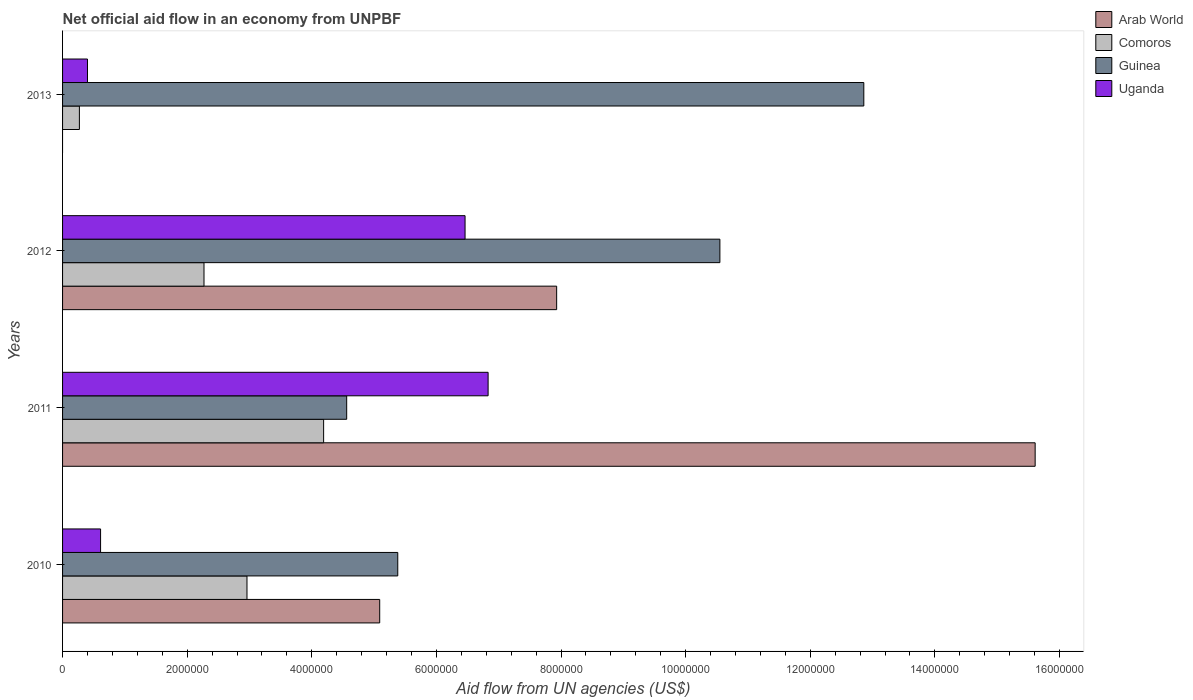How many different coloured bars are there?
Give a very brief answer. 4. Are the number of bars on each tick of the Y-axis equal?
Provide a short and direct response. No. How many bars are there on the 4th tick from the top?
Your response must be concise. 4. How many bars are there on the 4th tick from the bottom?
Offer a very short reply. 3. Across all years, what is the maximum net official aid flow in Comoros?
Offer a very short reply. 4.19e+06. Across all years, what is the minimum net official aid flow in Guinea?
Provide a short and direct response. 4.56e+06. What is the total net official aid flow in Uganda in the graph?
Your answer should be compact. 1.43e+07. What is the difference between the net official aid flow in Uganda in 2012 and that in 2013?
Offer a very short reply. 6.06e+06. What is the difference between the net official aid flow in Guinea in 2013 and the net official aid flow in Uganda in 2012?
Give a very brief answer. 6.40e+06. What is the average net official aid flow in Uganda per year?
Ensure brevity in your answer.  3.58e+06. In the year 2012, what is the difference between the net official aid flow in Uganda and net official aid flow in Comoros?
Make the answer very short. 4.19e+06. In how many years, is the net official aid flow in Guinea greater than 8400000 US$?
Provide a succinct answer. 2. What is the ratio of the net official aid flow in Arab World in 2010 to that in 2012?
Provide a succinct answer. 0.64. Is the net official aid flow in Guinea in 2011 less than that in 2012?
Provide a short and direct response. Yes. What is the difference between the highest and the second highest net official aid flow in Arab World?
Offer a very short reply. 7.68e+06. What is the difference between the highest and the lowest net official aid flow in Comoros?
Offer a terse response. 3.92e+06. Is the sum of the net official aid flow in Comoros in 2010 and 2013 greater than the maximum net official aid flow in Guinea across all years?
Offer a terse response. No. Is it the case that in every year, the sum of the net official aid flow in Arab World and net official aid flow in Uganda is greater than the sum of net official aid flow in Comoros and net official aid flow in Guinea?
Make the answer very short. No. Are all the bars in the graph horizontal?
Offer a very short reply. Yes. What is the difference between two consecutive major ticks on the X-axis?
Provide a succinct answer. 2.00e+06. Are the values on the major ticks of X-axis written in scientific E-notation?
Your answer should be very brief. No. Does the graph contain any zero values?
Ensure brevity in your answer.  Yes. Does the graph contain grids?
Offer a very short reply. No. What is the title of the graph?
Provide a succinct answer. Net official aid flow in an economy from UNPBF. What is the label or title of the X-axis?
Make the answer very short. Aid flow from UN agencies (US$). What is the label or title of the Y-axis?
Offer a terse response. Years. What is the Aid flow from UN agencies (US$) in Arab World in 2010?
Make the answer very short. 5.09e+06. What is the Aid flow from UN agencies (US$) of Comoros in 2010?
Your answer should be very brief. 2.96e+06. What is the Aid flow from UN agencies (US$) in Guinea in 2010?
Keep it short and to the point. 5.38e+06. What is the Aid flow from UN agencies (US$) in Uganda in 2010?
Offer a terse response. 6.10e+05. What is the Aid flow from UN agencies (US$) in Arab World in 2011?
Provide a succinct answer. 1.56e+07. What is the Aid flow from UN agencies (US$) in Comoros in 2011?
Give a very brief answer. 4.19e+06. What is the Aid flow from UN agencies (US$) of Guinea in 2011?
Your answer should be compact. 4.56e+06. What is the Aid flow from UN agencies (US$) in Uganda in 2011?
Offer a very short reply. 6.83e+06. What is the Aid flow from UN agencies (US$) in Arab World in 2012?
Your answer should be very brief. 7.93e+06. What is the Aid flow from UN agencies (US$) in Comoros in 2012?
Make the answer very short. 2.27e+06. What is the Aid flow from UN agencies (US$) of Guinea in 2012?
Your answer should be compact. 1.06e+07. What is the Aid flow from UN agencies (US$) in Uganda in 2012?
Give a very brief answer. 6.46e+06. What is the Aid flow from UN agencies (US$) in Arab World in 2013?
Your response must be concise. 0. What is the Aid flow from UN agencies (US$) in Comoros in 2013?
Your answer should be very brief. 2.70e+05. What is the Aid flow from UN agencies (US$) in Guinea in 2013?
Ensure brevity in your answer.  1.29e+07. What is the Aid flow from UN agencies (US$) in Uganda in 2013?
Your answer should be compact. 4.00e+05. Across all years, what is the maximum Aid flow from UN agencies (US$) in Arab World?
Ensure brevity in your answer.  1.56e+07. Across all years, what is the maximum Aid flow from UN agencies (US$) of Comoros?
Your response must be concise. 4.19e+06. Across all years, what is the maximum Aid flow from UN agencies (US$) of Guinea?
Your answer should be very brief. 1.29e+07. Across all years, what is the maximum Aid flow from UN agencies (US$) in Uganda?
Your answer should be compact. 6.83e+06. Across all years, what is the minimum Aid flow from UN agencies (US$) in Guinea?
Provide a succinct answer. 4.56e+06. What is the total Aid flow from UN agencies (US$) in Arab World in the graph?
Provide a short and direct response. 2.86e+07. What is the total Aid flow from UN agencies (US$) of Comoros in the graph?
Provide a short and direct response. 9.69e+06. What is the total Aid flow from UN agencies (US$) in Guinea in the graph?
Provide a short and direct response. 3.34e+07. What is the total Aid flow from UN agencies (US$) of Uganda in the graph?
Offer a very short reply. 1.43e+07. What is the difference between the Aid flow from UN agencies (US$) of Arab World in 2010 and that in 2011?
Provide a short and direct response. -1.05e+07. What is the difference between the Aid flow from UN agencies (US$) of Comoros in 2010 and that in 2011?
Provide a succinct answer. -1.23e+06. What is the difference between the Aid flow from UN agencies (US$) in Guinea in 2010 and that in 2011?
Your response must be concise. 8.20e+05. What is the difference between the Aid flow from UN agencies (US$) of Uganda in 2010 and that in 2011?
Give a very brief answer. -6.22e+06. What is the difference between the Aid flow from UN agencies (US$) of Arab World in 2010 and that in 2012?
Provide a succinct answer. -2.84e+06. What is the difference between the Aid flow from UN agencies (US$) of Comoros in 2010 and that in 2012?
Offer a terse response. 6.90e+05. What is the difference between the Aid flow from UN agencies (US$) in Guinea in 2010 and that in 2012?
Provide a short and direct response. -5.17e+06. What is the difference between the Aid flow from UN agencies (US$) of Uganda in 2010 and that in 2012?
Your answer should be compact. -5.85e+06. What is the difference between the Aid flow from UN agencies (US$) of Comoros in 2010 and that in 2013?
Give a very brief answer. 2.69e+06. What is the difference between the Aid flow from UN agencies (US$) of Guinea in 2010 and that in 2013?
Provide a succinct answer. -7.48e+06. What is the difference between the Aid flow from UN agencies (US$) in Arab World in 2011 and that in 2012?
Give a very brief answer. 7.68e+06. What is the difference between the Aid flow from UN agencies (US$) of Comoros in 2011 and that in 2012?
Your answer should be very brief. 1.92e+06. What is the difference between the Aid flow from UN agencies (US$) of Guinea in 2011 and that in 2012?
Give a very brief answer. -5.99e+06. What is the difference between the Aid flow from UN agencies (US$) in Comoros in 2011 and that in 2013?
Make the answer very short. 3.92e+06. What is the difference between the Aid flow from UN agencies (US$) of Guinea in 2011 and that in 2013?
Your answer should be very brief. -8.30e+06. What is the difference between the Aid flow from UN agencies (US$) in Uganda in 2011 and that in 2013?
Give a very brief answer. 6.43e+06. What is the difference between the Aid flow from UN agencies (US$) of Guinea in 2012 and that in 2013?
Your answer should be very brief. -2.31e+06. What is the difference between the Aid flow from UN agencies (US$) in Uganda in 2012 and that in 2013?
Offer a terse response. 6.06e+06. What is the difference between the Aid flow from UN agencies (US$) in Arab World in 2010 and the Aid flow from UN agencies (US$) in Guinea in 2011?
Keep it short and to the point. 5.30e+05. What is the difference between the Aid flow from UN agencies (US$) of Arab World in 2010 and the Aid flow from UN agencies (US$) of Uganda in 2011?
Make the answer very short. -1.74e+06. What is the difference between the Aid flow from UN agencies (US$) in Comoros in 2010 and the Aid flow from UN agencies (US$) in Guinea in 2011?
Make the answer very short. -1.60e+06. What is the difference between the Aid flow from UN agencies (US$) of Comoros in 2010 and the Aid flow from UN agencies (US$) of Uganda in 2011?
Give a very brief answer. -3.87e+06. What is the difference between the Aid flow from UN agencies (US$) in Guinea in 2010 and the Aid flow from UN agencies (US$) in Uganda in 2011?
Give a very brief answer. -1.45e+06. What is the difference between the Aid flow from UN agencies (US$) in Arab World in 2010 and the Aid flow from UN agencies (US$) in Comoros in 2012?
Your response must be concise. 2.82e+06. What is the difference between the Aid flow from UN agencies (US$) in Arab World in 2010 and the Aid flow from UN agencies (US$) in Guinea in 2012?
Keep it short and to the point. -5.46e+06. What is the difference between the Aid flow from UN agencies (US$) of Arab World in 2010 and the Aid flow from UN agencies (US$) of Uganda in 2012?
Make the answer very short. -1.37e+06. What is the difference between the Aid flow from UN agencies (US$) in Comoros in 2010 and the Aid flow from UN agencies (US$) in Guinea in 2012?
Offer a very short reply. -7.59e+06. What is the difference between the Aid flow from UN agencies (US$) in Comoros in 2010 and the Aid flow from UN agencies (US$) in Uganda in 2012?
Provide a succinct answer. -3.50e+06. What is the difference between the Aid flow from UN agencies (US$) of Guinea in 2010 and the Aid flow from UN agencies (US$) of Uganda in 2012?
Offer a very short reply. -1.08e+06. What is the difference between the Aid flow from UN agencies (US$) of Arab World in 2010 and the Aid flow from UN agencies (US$) of Comoros in 2013?
Your answer should be compact. 4.82e+06. What is the difference between the Aid flow from UN agencies (US$) of Arab World in 2010 and the Aid flow from UN agencies (US$) of Guinea in 2013?
Provide a succinct answer. -7.77e+06. What is the difference between the Aid flow from UN agencies (US$) in Arab World in 2010 and the Aid flow from UN agencies (US$) in Uganda in 2013?
Make the answer very short. 4.69e+06. What is the difference between the Aid flow from UN agencies (US$) in Comoros in 2010 and the Aid flow from UN agencies (US$) in Guinea in 2013?
Your response must be concise. -9.90e+06. What is the difference between the Aid flow from UN agencies (US$) of Comoros in 2010 and the Aid flow from UN agencies (US$) of Uganda in 2013?
Keep it short and to the point. 2.56e+06. What is the difference between the Aid flow from UN agencies (US$) in Guinea in 2010 and the Aid flow from UN agencies (US$) in Uganda in 2013?
Keep it short and to the point. 4.98e+06. What is the difference between the Aid flow from UN agencies (US$) in Arab World in 2011 and the Aid flow from UN agencies (US$) in Comoros in 2012?
Provide a short and direct response. 1.33e+07. What is the difference between the Aid flow from UN agencies (US$) of Arab World in 2011 and the Aid flow from UN agencies (US$) of Guinea in 2012?
Provide a short and direct response. 5.06e+06. What is the difference between the Aid flow from UN agencies (US$) of Arab World in 2011 and the Aid flow from UN agencies (US$) of Uganda in 2012?
Your response must be concise. 9.15e+06. What is the difference between the Aid flow from UN agencies (US$) in Comoros in 2011 and the Aid flow from UN agencies (US$) in Guinea in 2012?
Your answer should be compact. -6.36e+06. What is the difference between the Aid flow from UN agencies (US$) of Comoros in 2011 and the Aid flow from UN agencies (US$) of Uganda in 2012?
Give a very brief answer. -2.27e+06. What is the difference between the Aid flow from UN agencies (US$) of Guinea in 2011 and the Aid flow from UN agencies (US$) of Uganda in 2012?
Make the answer very short. -1.90e+06. What is the difference between the Aid flow from UN agencies (US$) in Arab World in 2011 and the Aid flow from UN agencies (US$) in Comoros in 2013?
Ensure brevity in your answer.  1.53e+07. What is the difference between the Aid flow from UN agencies (US$) in Arab World in 2011 and the Aid flow from UN agencies (US$) in Guinea in 2013?
Provide a short and direct response. 2.75e+06. What is the difference between the Aid flow from UN agencies (US$) in Arab World in 2011 and the Aid flow from UN agencies (US$) in Uganda in 2013?
Keep it short and to the point. 1.52e+07. What is the difference between the Aid flow from UN agencies (US$) in Comoros in 2011 and the Aid flow from UN agencies (US$) in Guinea in 2013?
Make the answer very short. -8.67e+06. What is the difference between the Aid flow from UN agencies (US$) of Comoros in 2011 and the Aid flow from UN agencies (US$) of Uganda in 2013?
Keep it short and to the point. 3.79e+06. What is the difference between the Aid flow from UN agencies (US$) of Guinea in 2011 and the Aid flow from UN agencies (US$) of Uganda in 2013?
Make the answer very short. 4.16e+06. What is the difference between the Aid flow from UN agencies (US$) in Arab World in 2012 and the Aid flow from UN agencies (US$) in Comoros in 2013?
Your answer should be very brief. 7.66e+06. What is the difference between the Aid flow from UN agencies (US$) in Arab World in 2012 and the Aid flow from UN agencies (US$) in Guinea in 2013?
Your answer should be compact. -4.93e+06. What is the difference between the Aid flow from UN agencies (US$) of Arab World in 2012 and the Aid flow from UN agencies (US$) of Uganda in 2013?
Ensure brevity in your answer.  7.53e+06. What is the difference between the Aid flow from UN agencies (US$) in Comoros in 2012 and the Aid flow from UN agencies (US$) in Guinea in 2013?
Your response must be concise. -1.06e+07. What is the difference between the Aid flow from UN agencies (US$) of Comoros in 2012 and the Aid flow from UN agencies (US$) of Uganda in 2013?
Your answer should be very brief. 1.87e+06. What is the difference between the Aid flow from UN agencies (US$) of Guinea in 2012 and the Aid flow from UN agencies (US$) of Uganda in 2013?
Offer a terse response. 1.02e+07. What is the average Aid flow from UN agencies (US$) of Arab World per year?
Offer a very short reply. 7.16e+06. What is the average Aid flow from UN agencies (US$) in Comoros per year?
Give a very brief answer. 2.42e+06. What is the average Aid flow from UN agencies (US$) in Guinea per year?
Ensure brevity in your answer.  8.34e+06. What is the average Aid flow from UN agencies (US$) of Uganda per year?
Provide a short and direct response. 3.58e+06. In the year 2010, what is the difference between the Aid flow from UN agencies (US$) in Arab World and Aid flow from UN agencies (US$) in Comoros?
Make the answer very short. 2.13e+06. In the year 2010, what is the difference between the Aid flow from UN agencies (US$) of Arab World and Aid flow from UN agencies (US$) of Guinea?
Ensure brevity in your answer.  -2.90e+05. In the year 2010, what is the difference between the Aid flow from UN agencies (US$) in Arab World and Aid flow from UN agencies (US$) in Uganda?
Offer a terse response. 4.48e+06. In the year 2010, what is the difference between the Aid flow from UN agencies (US$) of Comoros and Aid flow from UN agencies (US$) of Guinea?
Provide a short and direct response. -2.42e+06. In the year 2010, what is the difference between the Aid flow from UN agencies (US$) in Comoros and Aid flow from UN agencies (US$) in Uganda?
Make the answer very short. 2.35e+06. In the year 2010, what is the difference between the Aid flow from UN agencies (US$) of Guinea and Aid flow from UN agencies (US$) of Uganda?
Offer a very short reply. 4.77e+06. In the year 2011, what is the difference between the Aid flow from UN agencies (US$) of Arab World and Aid flow from UN agencies (US$) of Comoros?
Offer a terse response. 1.14e+07. In the year 2011, what is the difference between the Aid flow from UN agencies (US$) of Arab World and Aid flow from UN agencies (US$) of Guinea?
Offer a terse response. 1.10e+07. In the year 2011, what is the difference between the Aid flow from UN agencies (US$) in Arab World and Aid flow from UN agencies (US$) in Uganda?
Ensure brevity in your answer.  8.78e+06. In the year 2011, what is the difference between the Aid flow from UN agencies (US$) in Comoros and Aid flow from UN agencies (US$) in Guinea?
Give a very brief answer. -3.70e+05. In the year 2011, what is the difference between the Aid flow from UN agencies (US$) of Comoros and Aid flow from UN agencies (US$) of Uganda?
Your answer should be compact. -2.64e+06. In the year 2011, what is the difference between the Aid flow from UN agencies (US$) of Guinea and Aid flow from UN agencies (US$) of Uganda?
Provide a short and direct response. -2.27e+06. In the year 2012, what is the difference between the Aid flow from UN agencies (US$) of Arab World and Aid flow from UN agencies (US$) of Comoros?
Your answer should be very brief. 5.66e+06. In the year 2012, what is the difference between the Aid flow from UN agencies (US$) in Arab World and Aid flow from UN agencies (US$) in Guinea?
Your answer should be very brief. -2.62e+06. In the year 2012, what is the difference between the Aid flow from UN agencies (US$) of Arab World and Aid flow from UN agencies (US$) of Uganda?
Give a very brief answer. 1.47e+06. In the year 2012, what is the difference between the Aid flow from UN agencies (US$) in Comoros and Aid flow from UN agencies (US$) in Guinea?
Your answer should be very brief. -8.28e+06. In the year 2012, what is the difference between the Aid flow from UN agencies (US$) in Comoros and Aid flow from UN agencies (US$) in Uganda?
Your response must be concise. -4.19e+06. In the year 2012, what is the difference between the Aid flow from UN agencies (US$) of Guinea and Aid flow from UN agencies (US$) of Uganda?
Your answer should be compact. 4.09e+06. In the year 2013, what is the difference between the Aid flow from UN agencies (US$) in Comoros and Aid flow from UN agencies (US$) in Guinea?
Your answer should be very brief. -1.26e+07. In the year 2013, what is the difference between the Aid flow from UN agencies (US$) in Guinea and Aid flow from UN agencies (US$) in Uganda?
Offer a very short reply. 1.25e+07. What is the ratio of the Aid flow from UN agencies (US$) of Arab World in 2010 to that in 2011?
Keep it short and to the point. 0.33. What is the ratio of the Aid flow from UN agencies (US$) in Comoros in 2010 to that in 2011?
Make the answer very short. 0.71. What is the ratio of the Aid flow from UN agencies (US$) of Guinea in 2010 to that in 2011?
Ensure brevity in your answer.  1.18. What is the ratio of the Aid flow from UN agencies (US$) of Uganda in 2010 to that in 2011?
Your answer should be very brief. 0.09. What is the ratio of the Aid flow from UN agencies (US$) of Arab World in 2010 to that in 2012?
Make the answer very short. 0.64. What is the ratio of the Aid flow from UN agencies (US$) in Comoros in 2010 to that in 2012?
Ensure brevity in your answer.  1.3. What is the ratio of the Aid flow from UN agencies (US$) of Guinea in 2010 to that in 2012?
Your answer should be very brief. 0.51. What is the ratio of the Aid flow from UN agencies (US$) in Uganda in 2010 to that in 2012?
Offer a terse response. 0.09. What is the ratio of the Aid flow from UN agencies (US$) in Comoros in 2010 to that in 2013?
Provide a succinct answer. 10.96. What is the ratio of the Aid flow from UN agencies (US$) in Guinea in 2010 to that in 2013?
Make the answer very short. 0.42. What is the ratio of the Aid flow from UN agencies (US$) of Uganda in 2010 to that in 2013?
Offer a very short reply. 1.52. What is the ratio of the Aid flow from UN agencies (US$) in Arab World in 2011 to that in 2012?
Provide a succinct answer. 1.97. What is the ratio of the Aid flow from UN agencies (US$) in Comoros in 2011 to that in 2012?
Give a very brief answer. 1.85. What is the ratio of the Aid flow from UN agencies (US$) in Guinea in 2011 to that in 2012?
Your answer should be very brief. 0.43. What is the ratio of the Aid flow from UN agencies (US$) of Uganda in 2011 to that in 2012?
Keep it short and to the point. 1.06. What is the ratio of the Aid flow from UN agencies (US$) in Comoros in 2011 to that in 2013?
Your answer should be compact. 15.52. What is the ratio of the Aid flow from UN agencies (US$) of Guinea in 2011 to that in 2013?
Ensure brevity in your answer.  0.35. What is the ratio of the Aid flow from UN agencies (US$) in Uganda in 2011 to that in 2013?
Give a very brief answer. 17.07. What is the ratio of the Aid flow from UN agencies (US$) of Comoros in 2012 to that in 2013?
Provide a short and direct response. 8.41. What is the ratio of the Aid flow from UN agencies (US$) of Guinea in 2012 to that in 2013?
Provide a succinct answer. 0.82. What is the ratio of the Aid flow from UN agencies (US$) in Uganda in 2012 to that in 2013?
Give a very brief answer. 16.15. What is the difference between the highest and the second highest Aid flow from UN agencies (US$) of Arab World?
Ensure brevity in your answer.  7.68e+06. What is the difference between the highest and the second highest Aid flow from UN agencies (US$) of Comoros?
Your answer should be compact. 1.23e+06. What is the difference between the highest and the second highest Aid flow from UN agencies (US$) of Guinea?
Give a very brief answer. 2.31e+06. What is the difference between the highest and the second highest Aid flow from UN agencies (US$) in Uganda?
Provide a succinct answer. 3.70e+05. What is the difference between the highest and the lowest Aid flow from UN agencies (US$) of Arab World?
Offer a very short reply. 1.56e+07. What is the difference between the highest and the lowest Aid flow from UN agencies (US$) of Comoros?
Keep it short and to the point. 3.92e+06. What is the difference between the highest and the lowest Aid flow from UN agencies (US$) of Guinea?
Offer a very short reply. 8.30e+06. What is the difference between the highest and the lowest Aid flow from UN agencies (US$) in Uganda?
Provide a succinct answer. 6.43e+06. 